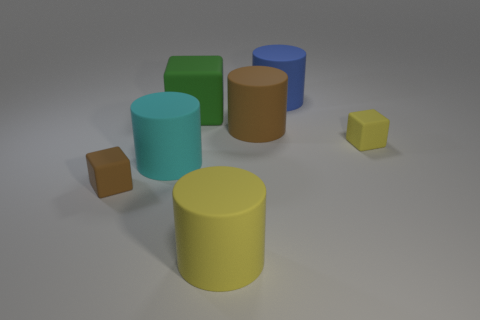Are the cylinder on the left side of the yellow rubber cylinder and the blue cylinder made of the same material?
Your response must be concise. Yes. What number of purple things are big metallic spheres or large matte cubes?
Keep it short and to the point. 0. Is there a tiny metallic cylinder of the same color as the big matte block?
Your answer should be compact. No. Is there a blue object that has the same material as the large cyan cylinder?
Provide a short and direct response. Yes. There is a rubber thing that is both behind the large brown cylinder and on the left side of the blue object; what is its shape?
Provide a succinct answer. Cube. How many tiny objects are purple rubber things or cylinders?
Provide a succinct answer. 0. What is the small yellow object made of?
Make the answer very short. Rubber. What number of other objects are the same shape as the large yellow matte thing?
Your answer should be compact. 3. The cyan object is what size?
Your answer should be compact. Large. What is the size of the cube that is on the left side of the tiny yellow cube and to the right of the small brown block?
Make the answer very short. Large. 